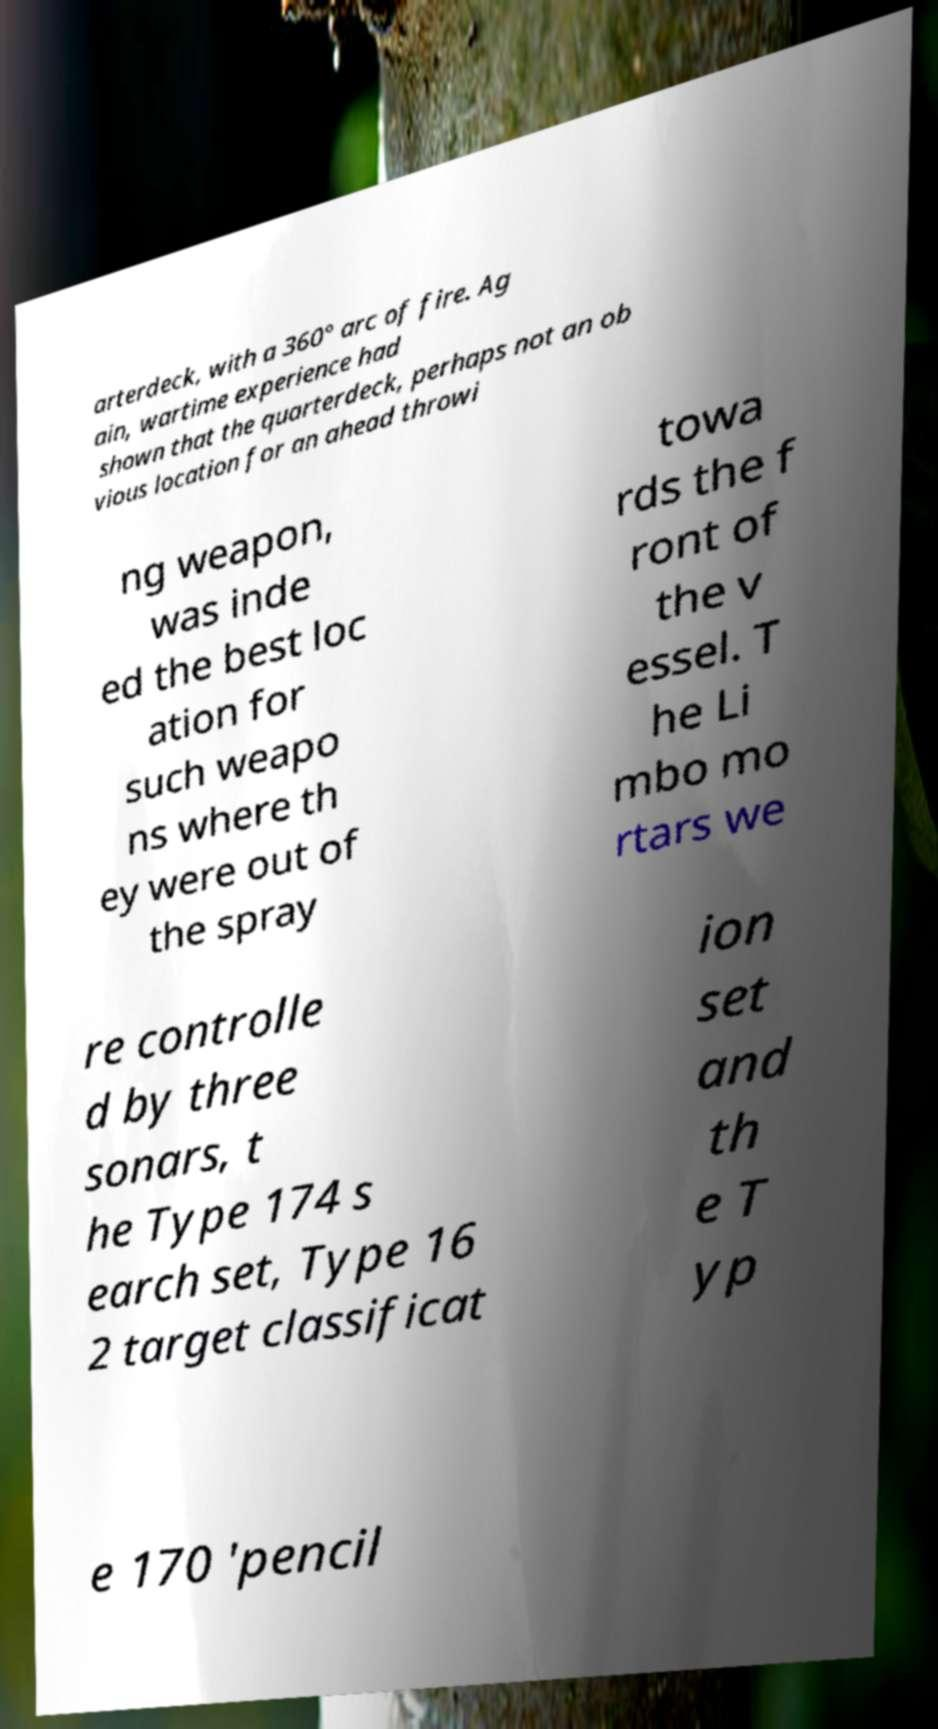Could you extract and type out the text from this image? arterdeck, with a 360° arc of fire. Ag ain, wartime experience had shown that the quarterdeck, perhaps not an ob vious location for an ahead throwi ng weapon, was inde ed the best loc ation for such weapo ns where th ey were out of the spray towa rds the f ront of the v essel. T he Li mbo mo rtars we re controlle d by three sonars, t he Type 174 s earch set, Type 16 2 target classificat ion set and th e T yp e 170 'pencil 